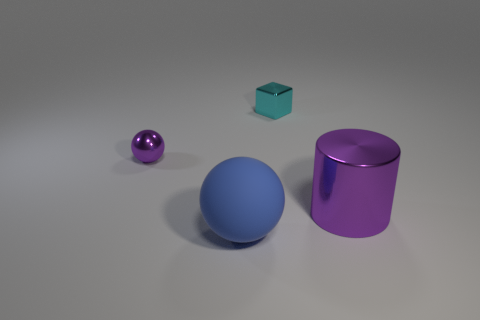What number of large metallic objects have the same color as the small metal sphere?
Make the answer very short. 1. What number of tiny purple things have the same material as the cylinder?
Keep it short and to the point. 1. How many things are big yellow balls or shiny things left of the cyan shiny cube?
Offer a terse response. 1. What color is the large thing that is on the right side of the shiny object that is behind the purple object that is left of the blue matte thing?
Ensure brevity in your answer.  Purple. How big is the shiny thing that is behind the tiny shiny sphere?
Provide a succinct answer. Small. What number of small things are purple shiny cylinders or blue metallic cylinders?
Provide a succinct answer. 0. There is a metallic object that is behind the large metallic thing and right of the big ball; what is its color?
Offer a very short reply. Cyan. Are there any big blue shiny things that have the same shape as the rubber object?
Offer a very short reply. No. What is the material of the small cyan object?
Provide a short and direct response. Metal. There is a rubber thing; are there any big blue balls in front of it?
Make the answer very short. No. 